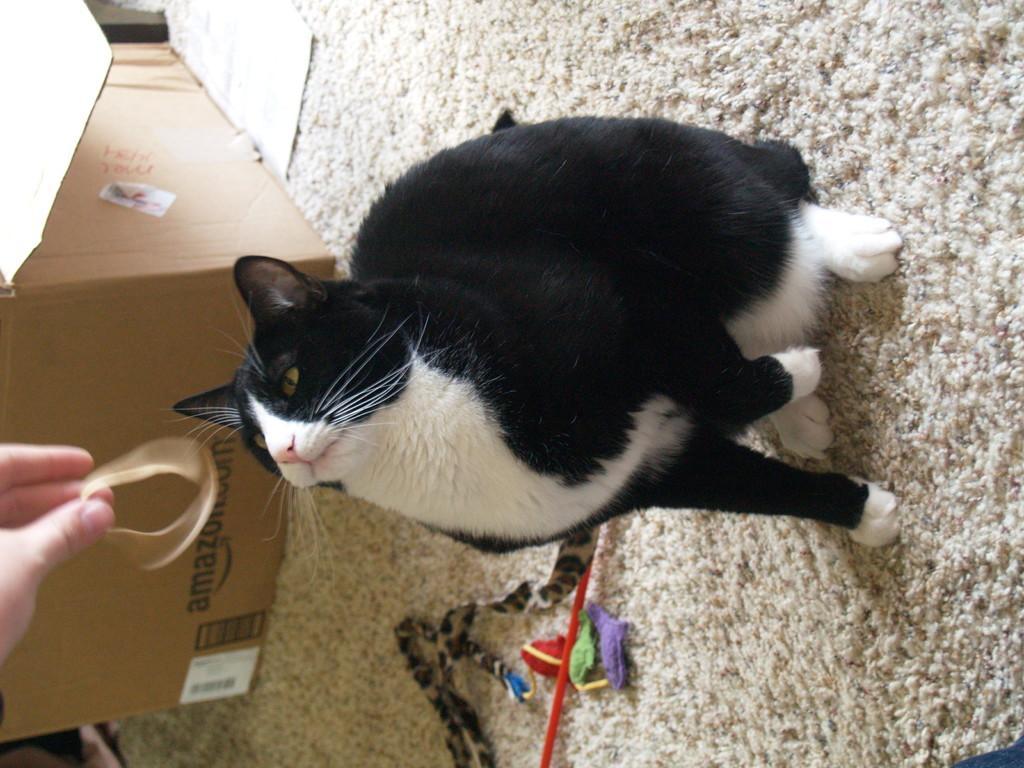Could you give a brief overview of what you see in this image? In this image on the floor there is a carpet, ribbon, cartoon. A cat is sitting on the floor. In the left we can see a hand holding a ribbon. 